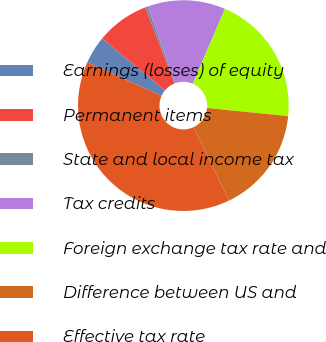<chart> <loc_0><loc_0><loc_500><loc_500><pie_chart><fcel>Earnings (losses) of equity<fcel>Permanent items<fcel>State and local income tax<fcel>Tax credits<fcel>Foreign exchange tax rate and<fcel>Difference between US and<fcel>Effective tax rate<nl><fcel>4.26%<fcel>8.1%<fcel>0.42%<fcel>11.95%<fcel>20.13%<fcel>16.29%<fcel>38.85%<nl></chart> 